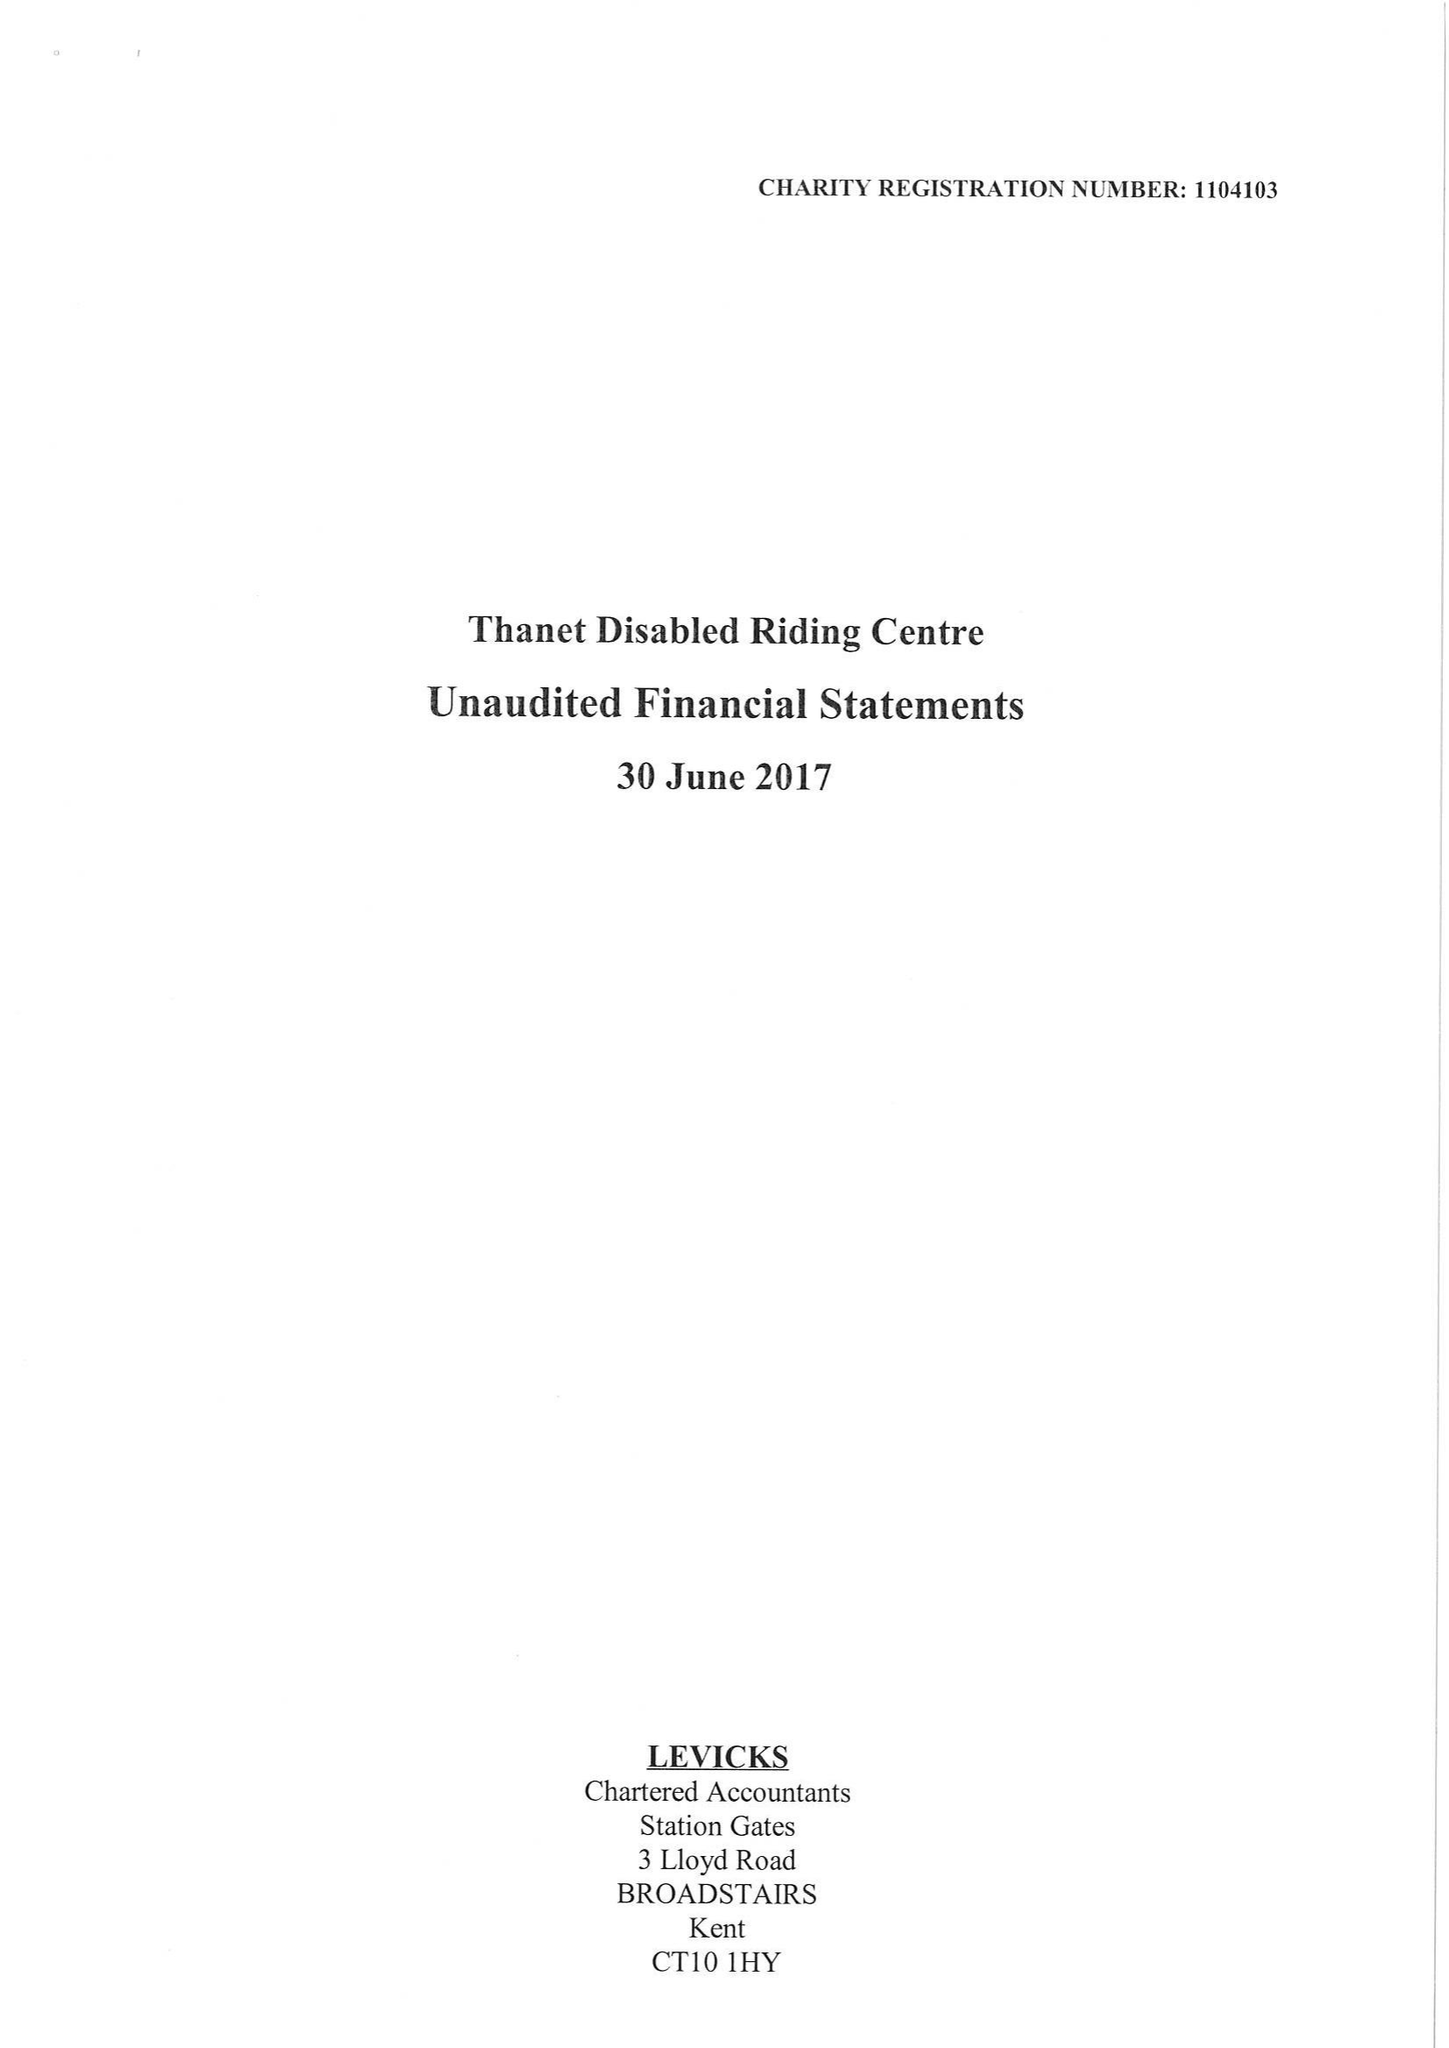What is the value for the address__postcode?
Answer the question using a single word or phrase. CT10 3AH 